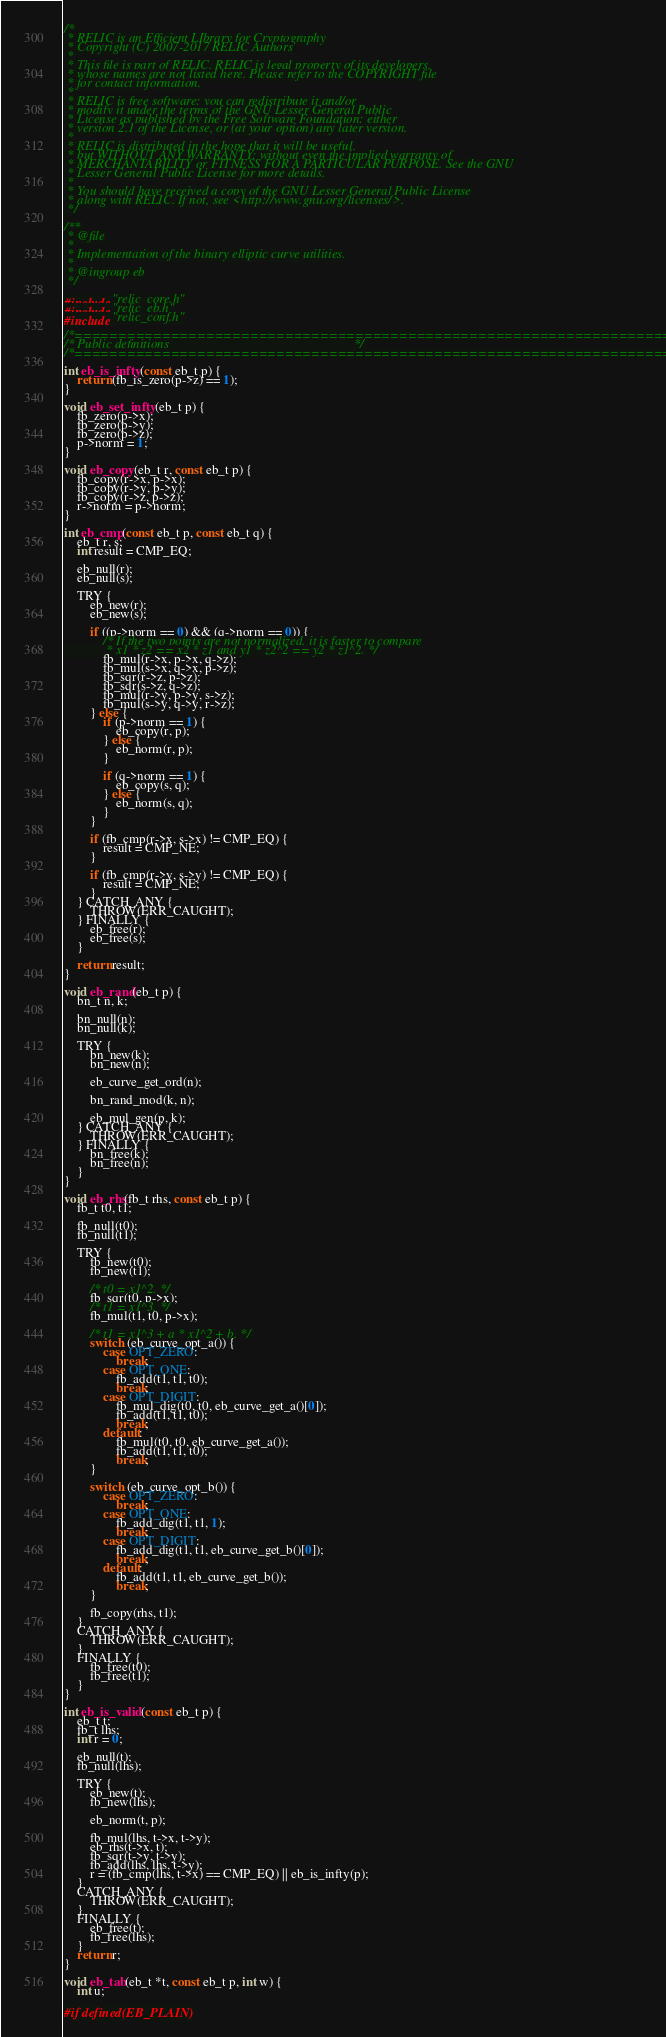<code> <loc_0><loc_0><loc_500><loc_500><_C_>/*
 * RELIC is an Efficient LIbrary for Cryptography
 * Copyright (C) 2007-2017 RELIC Authors
 *
 * This file is part of RELIC. RELIC is legal property of its developers,
 * whose names are not listed here. Please refer to the COPYRIGHT file
 * for contact information.
 *
 * RELIC is free software; you can redistribute it and/or
 * modify it under the terms of the GNU Lesser General Public
 * License as published by the Free Software Foundation; either
 * version 2.1 of the License, or (at your option) any later version.
 *
 * RELIC is distributed in the hope that it will be useful,
 * but WITHOUT ANY WARRANTY; without even the implied warranty of
 * MERCHANTABILITY or FITNESS FOR A PARTICULAR PURPOSE. See the GNU
 * Lesser General Public License for more details.
 *
 * You should have received a copy of the GNU Lesser General Public License
 * along with RELIC. If not, see <http://www.gnu.org/licenses/>.
 */

/**
 * @file
 *
 * Implementation of the binary elliptic curve utilities.
 *
 * @ingroup eb
 */

#include "relic_core.h"
#include "relic_eb.h"
#include "relic_conf.h"

/*============================================================================*/
/* Public definitions                                                         */
/*============================================================================*/

int eb_is_infty(const eb_t p) {
	return (fb_is_zero(p->z) == 1);
}

void eb_set_infty(eb_t p) {
	fb_zero(p->x);
	fb_zero(p->y);
	fb_zero(p->z);
	p->norm = 1;
}

void eb_copy(eb_t r, const eb_t p) {
	fb_copy(r->x, p->x);
	fb_copy(r->y, p->y);
	fb_copy(r->z, p->z);
	r->norm = p->norm;
}

int eb_cmp(const eb_t p, const eb_t q) {
    eb_t r, s;
    int result = CMP_EQ;

    eb_null(r);
    eb_null(s);

    TRY {
        eb_new(r);
        eb_new(s);

        if ((p->norm == 0) && (q->norm == 0)) {
            /* If the two points are not normalized, it is faster to compare
             * x1 * z2 == x2 * z1 and y1 * z2^2 == y2 * z1^2. */
            fb_mul(r->x, p->x, q->z);
            fb_mul(s->x, q->x, p->z);
            fb_sqr(r->z, p->z);
            fb_sqr(s->z, q->z);
            fb_mul(r->y, p->y, s->z);
            fb_mul(s->y, q->y, r->z);
        } else {
            if (p->norm == 1) {
                eb_copy(r, p);
            } else {
                eb_norm(r, p);
            }

            if (q->norm == 1) {
                eb_copy(s, q);
            } else {
                eb_norm(s, q);
            }
        }

        if (fb_cmp(r->x, s->x) != CMP_EQ) {
            result = CMP_NE;
        }

        if (fb_cmp(r->y, s->y) != CMP_EQ) {
            result = CMP_NE;
        }
    } CATCH_ANY {
        THROW(ERR_CAUGHT);
    } FINALLY {
        eb_free(r);
        eb_free(s);
    }

    return result;
}

void eb_rand(eb_t p) {
	bn_t n, k;

	bn_null(n);
	bn_null(k);

	TRY {
		bn_new(k);
		bn_new(n);

		eb_curve_get_ord(n);

		bn_rand_mod(k, n);

		eb_mul_gen(p, k);
	} CATCH_ANY {
		THROW(ERR_CAUGHT);
	} FINALLY {
		bn_free(k);
		bn_free(n);
	}
}

void eb_rhs(fb_t rhs, const eb_t p) {
	fb_t t0, t1;

	fb_null(t0);
	fb_null(t1);

	TRY {
		fb_new(t0);
		fb_new(t1);

		/* t0 = x1^2. */
		fb_sqr(t0, p->x);
		/* t1 = x1^3. */
		fb_mul(t1, t0, p->x);

		/* t1 = x1^3 + a * x1^2 + b. */
		switch (eb_curve_opt_a()) {
			case OPT_ZERO:
				break;
			case OPT_ONE:
				fb_add(t1, t1, t0);
				break;
			case OPT_DIGIT:
				fb_mul_dig(t0, t0, eb_curve_get_a()[0]);
				fb_add(t1, t1, t0);
				break;
			default:
				fb_mul(t0, t0, eb_curve_get_a());
				fb_add(t1, t1, t0);
				break;
		}

		switch (eb_curve_opt_b()) {
			case OPT_ZERO:
				break;
			case OPT_ONE:
				fb_add_dig(t1, t1, 1);
				break;
			case OPT_DIGIT:
				fb_add_dig(t1, t1, eb_curve_get_b()[0]);
				break;
			default:
				fb_add(t1, t1, eb_curve_get_b());
				break;
		}

		fb_copy(rhs, t1);
	}
	CATCH_ANY {
		THROW(ERR_CAUGHT);
	}
	FINALLY {
		fb_free(t0);
		fb_free(t1);
	}
}

int eb_is_valid(const eb_t p) {
	eb_t t;
	fb_t lhs;
	int r = 0;

	eb_null(t);
	fb_null(lhs);

	TRY {
		eb_new(t);
		fb_new(lhs);

		eb_norm(t, p);

		fb_mul(lhs, t->x, t->y);
		eb_rhs(t->x, t);
		fb_sqr(t->y, t->y);
		fb_add(lhs, lhs, t->y);
		r = (fb_cmp(lhs, t->x) == CMP_EQ) || eb_is_infty(p);
	}
	CATCH_ANY {
		THROW(ERR_CAUGHT);
	}
	FINALLY {
		eb_free(t);
		fb_free(lhs);
	}
	return r;
}

void eb_tab(eb_t *t, const eb_t p, int w) {
	int u;

#if defined(EB_PLAIN)</code> 